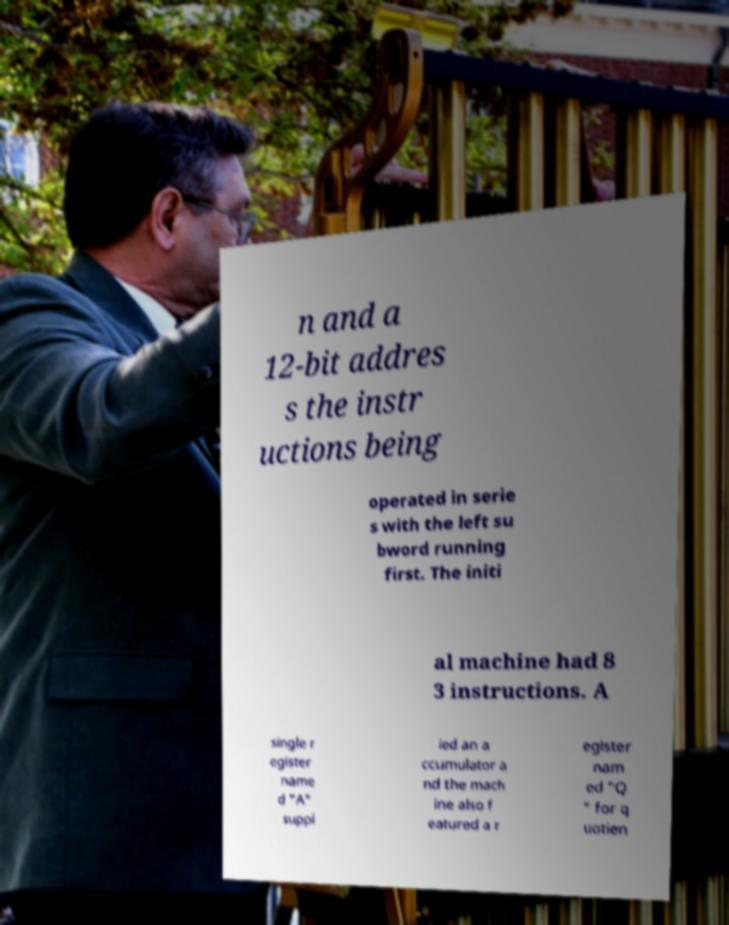What messages or text are displayed in this image? I need them in a readable, typed format. n and a 12-bit addres s the instr uctions being operated in serie s with the left su bword running first. The initi al machine had 8 3 instructions. A single r egister name d "A" suppl ied an a ccumulator a nd the mach ine also f eatured a r egister nam ed "Q " for q uotien 